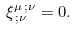<formula> <loc_0><loc_0><loc_500><loc_500>\xi ^ { \mu \, ; \nu } _ { \, ; \nu } = 0 .</formula> 